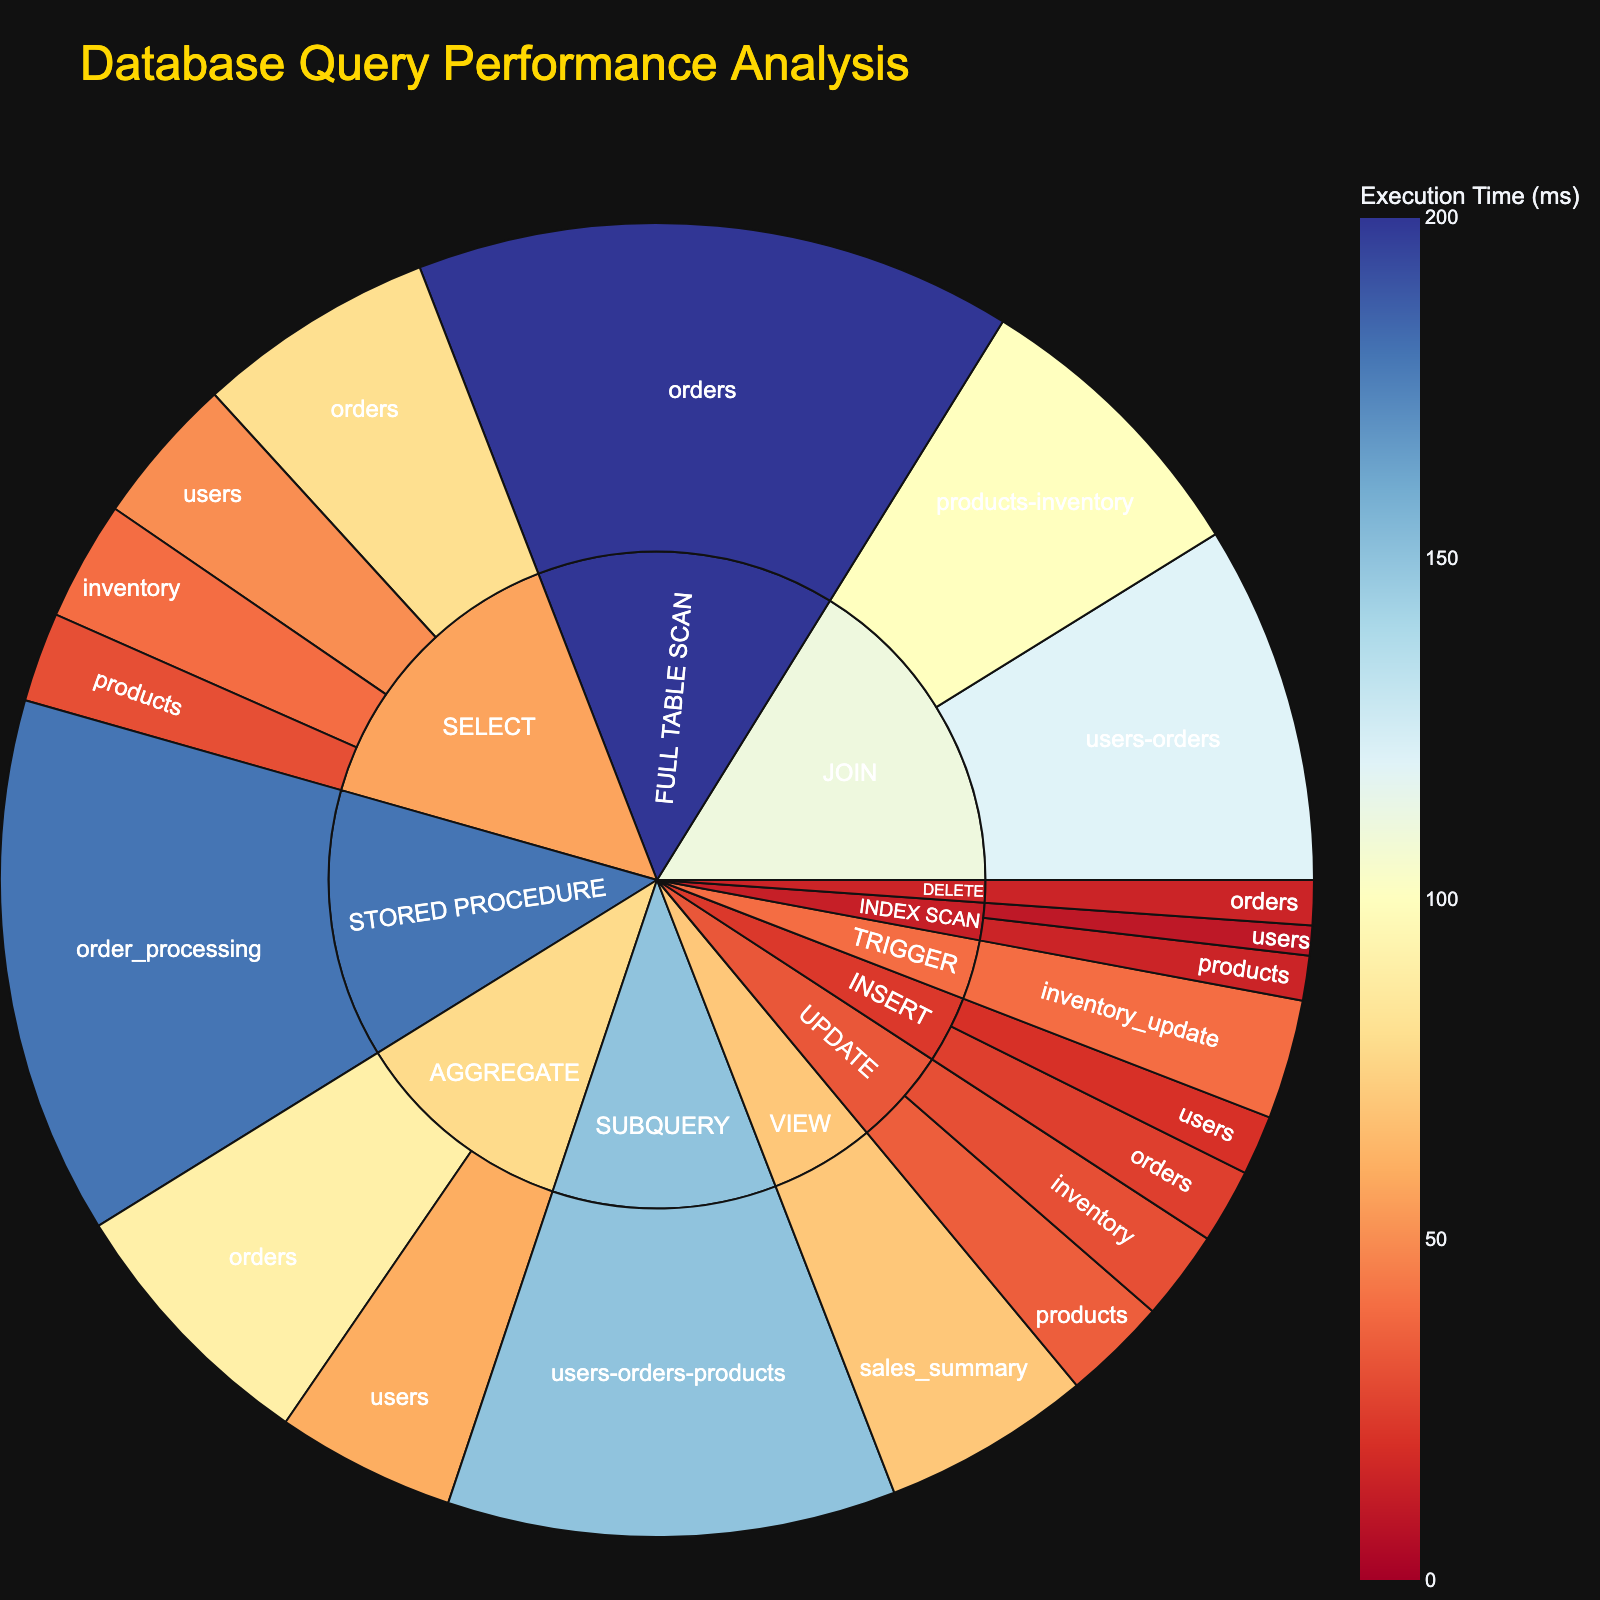What is the highest execution time displayed in the plot? To find the highest execution time, look at the outermost data points and check the one with the maximum value. According to the color intensity and value labels, the highest execution time is at 'FULL TABLE SCAN - orders'
Answer: 200 ms Which query type has the most subcategories of tables? Count the subcategories under each query type. 'SELECT' has the most with 4 subcategories: 'users', 'products','orders', and 'inventory'.
Answer: SELECT What's the total execution time for the 'AGGREGATE' query type? Sum the execution times for all subcategories under 'AGGREGATE'. 'users' has 60 ms and 'orders' has 90 ms, so the total is 60 + 90 = 150 ms.
Answer: 150 ms Which query type accessing 'users' table has the shortest execution time? Look at all the subtypes accessing 'users' table and compare their execution times. 'INDEX SCAN - users' has the shortest execution time with 10 ms.
Answer: INDEX SCAN - users Compare the execution times of 'AGGREGATE' and 'JOIN' operations. Which one takes longer? Sum the execution times for each subtype in both query types: 'AGGREGATE' (60 + 90 = 150 ms), 'JOIN' (120 + 100 = 220 ms). 'JOIN' takes longer.
Answer: JOIN What is the average execution time for all 'SELECT' query types? Sum the execution times for all 'SELECT' subtypes and divide by the number of subtypes (50 + 30 + 80 + 40 = 200, 200 / 4 = 50 ms).
Answer: 50 ms Which query accessing 'orders' table takes the least time? Check all entries accessing the 'orders' table and compare their execution times. The 'DELETE - orders' entry has the least execution time at 15 ms.
Answer: DELETE - orders How does the execution time span for 'UPDATE' compare to 'INSERT'? Compare the sum of execution times for both query types: 'UPDATE' (35 + 30 = 65 ms), 'INSERT' (20 + 25 = 45 ms). 'UPDATE' takes more time overall than 'INSERT'.
Answer: UPDATE What is the range of execution times for 'JOIN' operations? Identify the minimum and maximum execution times for 'JOIN'. The minimum is 100 ms (products-inventory) and the maximum is 120 ms (users-orders), giving a range of 20 ms.
Answer: 20 ms 